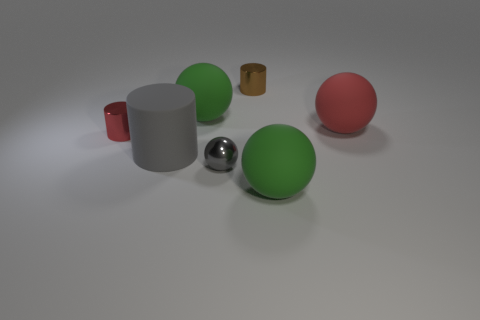What shape is the gray metallic object? The gray metallic object in the image is a perfect sphere, characterized by its reflective surface and smooth, circular outline, which distinguishes it from the other variously colored and shaped objects around it. 